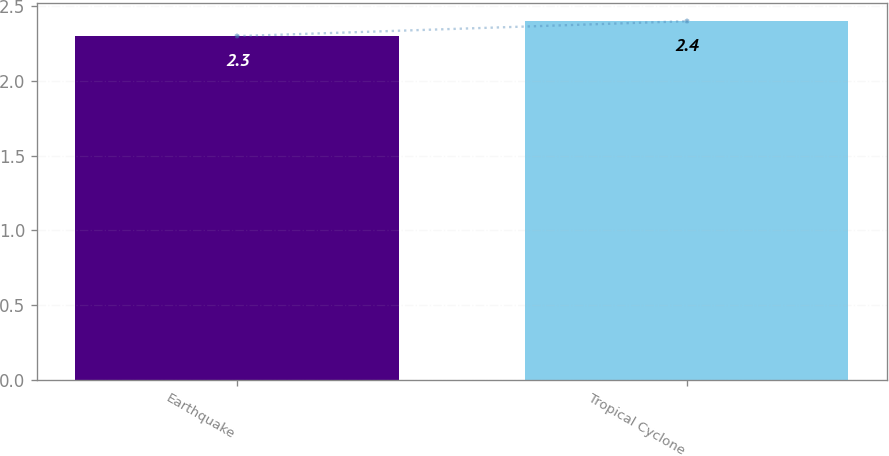<chart> <loc_0><loc_0><loc_500><loc_500><bar_chart><fcel>Earthquake<fcel>Tropical Cyclone<nl><fcel>2.3<fcel>2.4<nl></chart> 